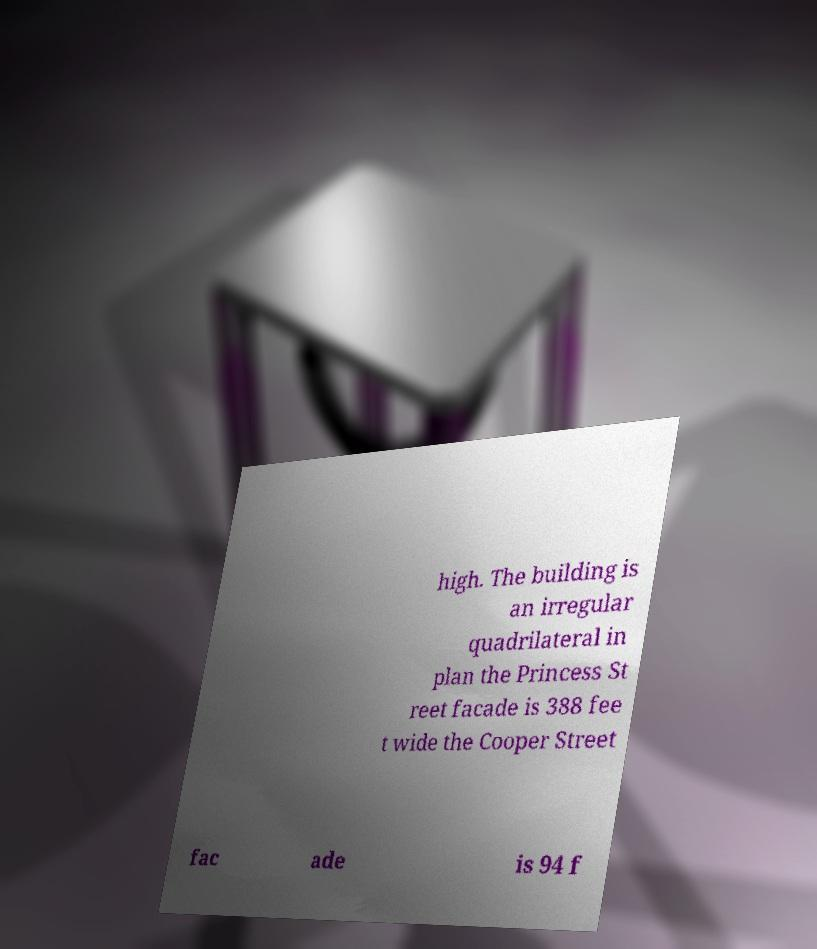Could you extract and type out the text from this image? high. The building is an irregular quadrilateral in plan the Princess St reet facade is 388 fee t wide the Cooper Street fac ade is 94 f 